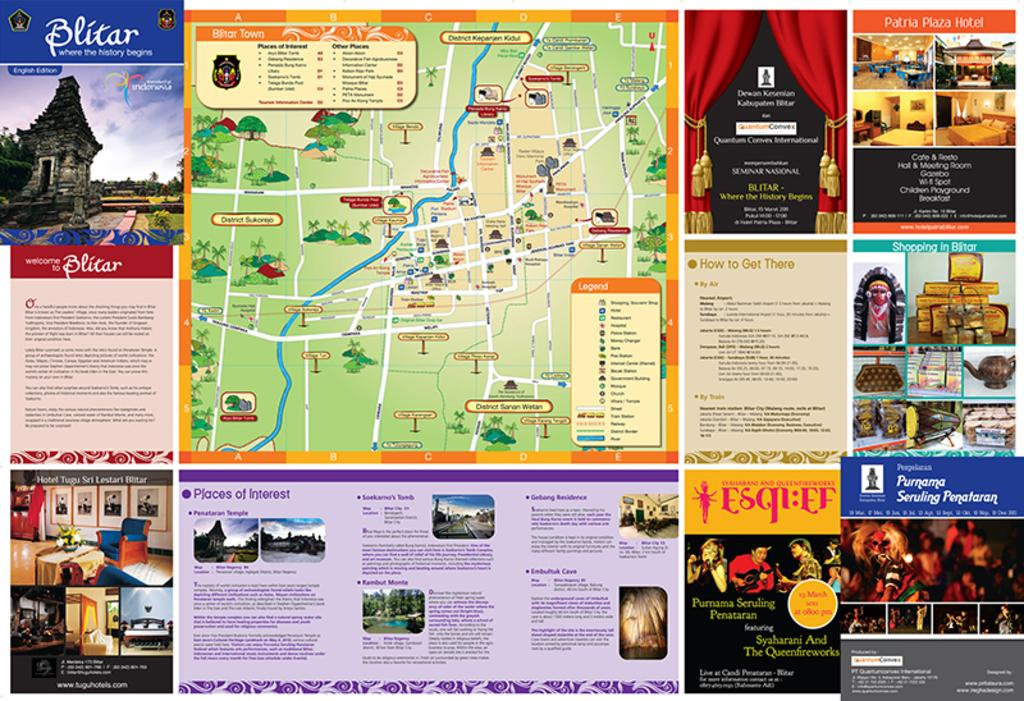<image>
Describe the image concisely. a map pamphlet with Blitar in the top left 